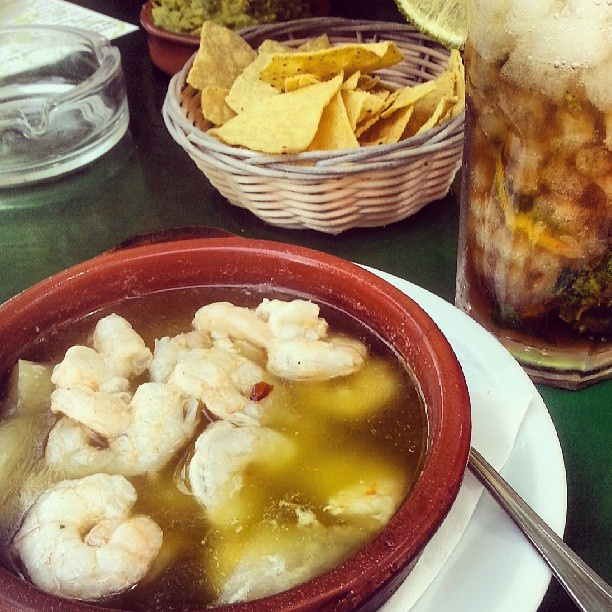Describe the objects in this image and their specific colors. I can see bowl in tan, khaki, maroon, brown, and beige tones, cup in tan, brown, maroon, and black tones, dining table in tan, black, gray, and darkgreen tones, and spoon in tan, gray, and darkgray tones in this image. 